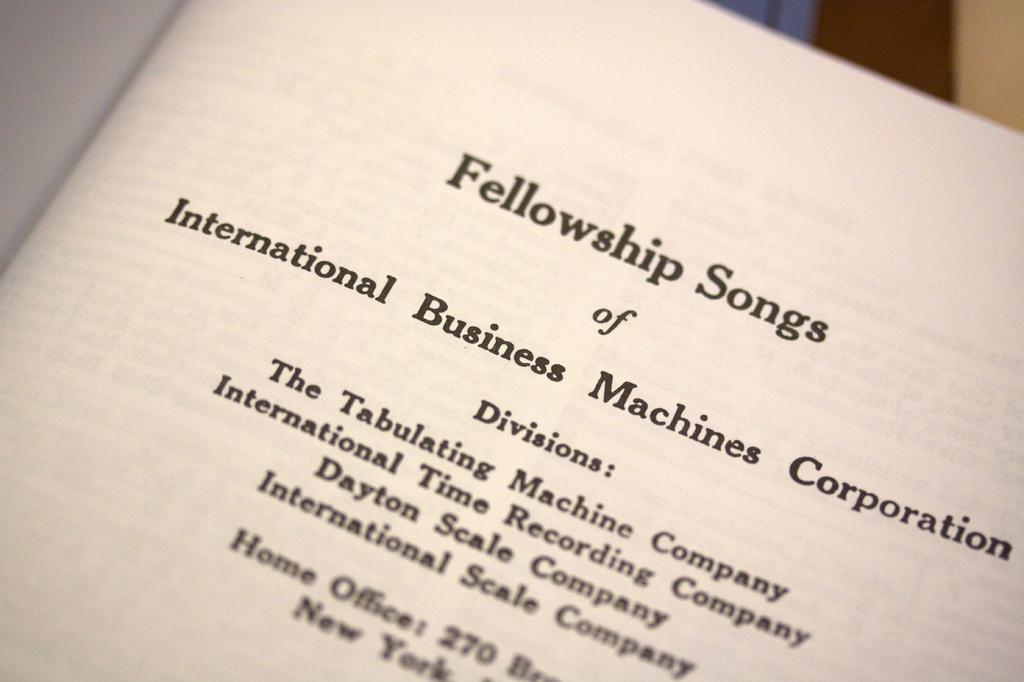<image>
Give a short and clear explanation of the subsequent image. A book page is titled Fellowship Songs and lists company names. 